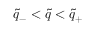<formula> <loc_0><loc_0><loc_500><loc_500>\tilde { q } _ { - } < \tilde { q } < \tilde { q } _ { + }</formula> 